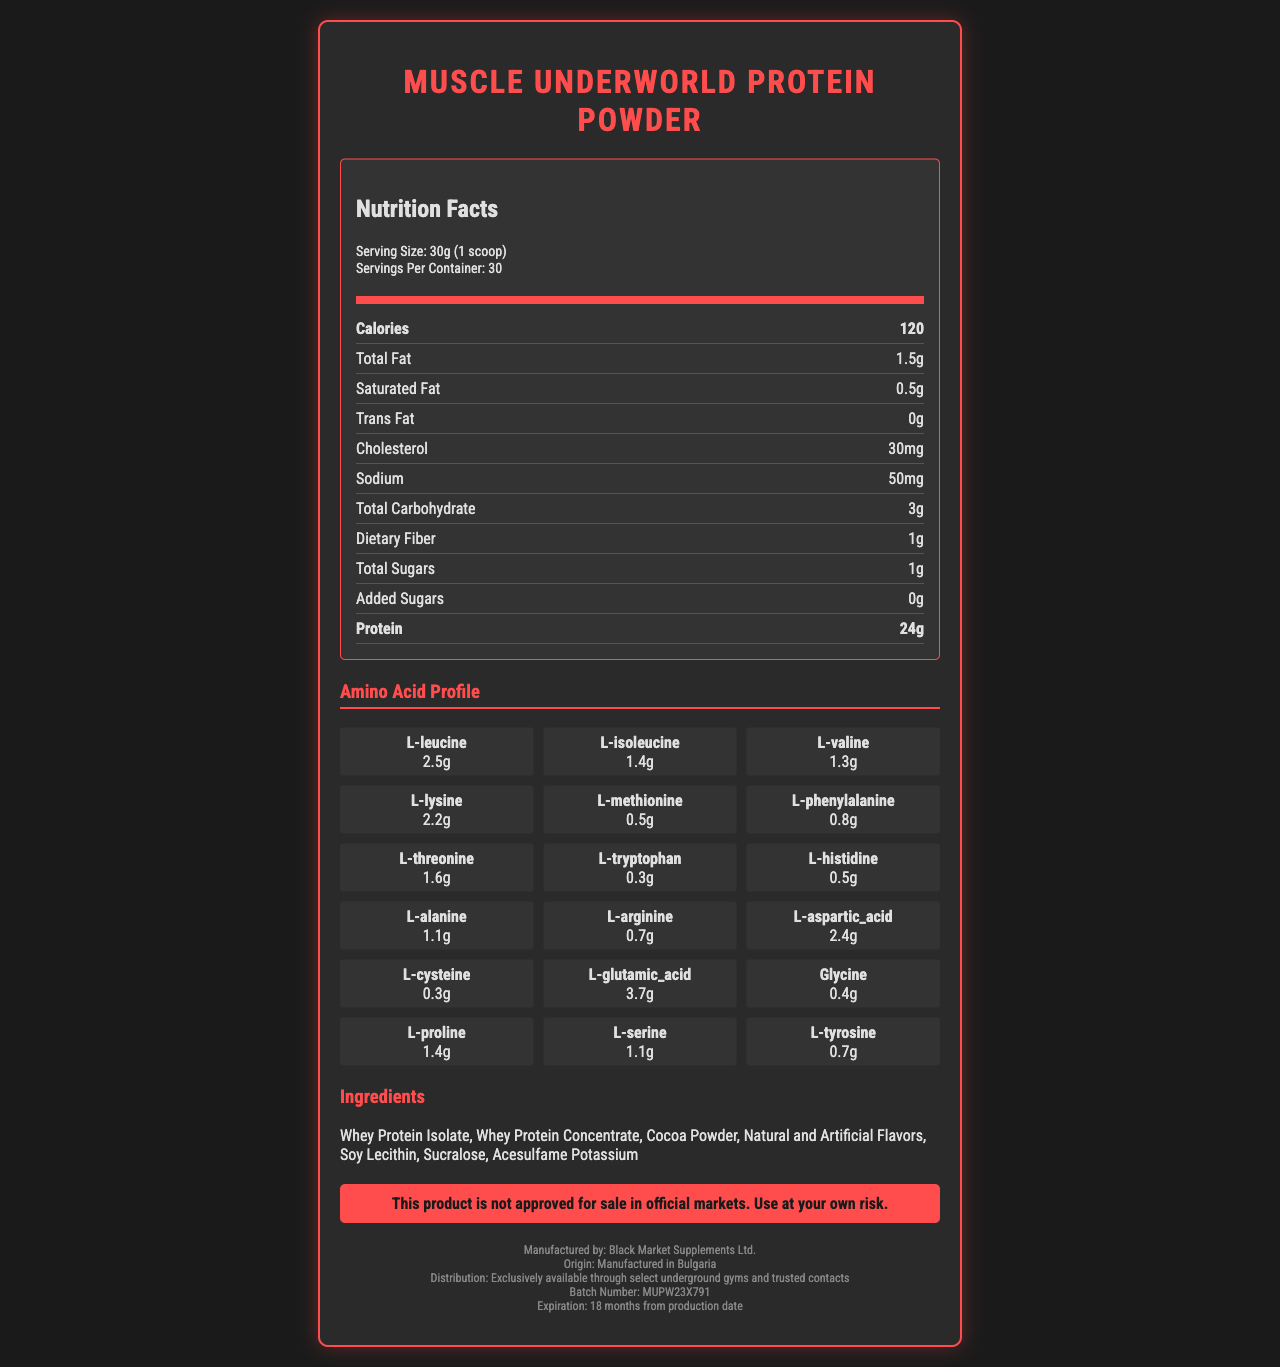what is the serving size of "Muscle Underworld Protein Powder"? The serving size is listed in the section "Serving Size."
Answer: 30g (1 scoop) how many calories are in one serving? The number of calories per serving is listed under the section "Calories."
Answer: 120 what is the total fat content per serving? The total fat content is listed under the section "Total Fat."
Answer: 1.5g how much protein is in each serving? The protein content per serving is listed under the section "Protein."
Answer: 24g what is the amount of L-Leucine per serving? The amount of L-Leucine is listed in the section "Amino Acid Profile."
Answer: 2.5g which two ingredients are primarily used in this protein powder? A. Soy Lecithin and Cocoa Powder B. Whey Protein Isolate and Whey Protein Concentrate C. Sucralose and Acesulfame Potassium D. Natural and Artificial Flavors The primary ingredients are listed in the "Ingredients" section, with the first two being Whey Protein Isolate and Whey Protein Concentrate.
Answer: B. Whey Protein Isolate and Whey Protein Concentrate how much calcium is in a serving? A. 50mg B. 160mg C. 120mg D. 100mg The amount of calcium per serving is listed under the section "Calcium."
Answer: C. 120mg is there any trans fat in this product? The amount of trans fat is listed as 0g in the "Trans Fat" section.
Answer: No does this product contain any added sugars? The amount of added sugars is listed as 0g in the "Added Sugars" section.
Answer: No is this product safe for individuals with peanut allergies? The allergen information states that the product is produced in a facility that also processes peanuts, but it does not confirm the absence of peanuts.
Answer: Cannot be determined what is the country of origin of "Muscle Underworld Protein Powder"? The country of origin is listed as "Manufactured in Bulgaria" in the footer.
Answer: Manufactured in Bulgaria what is the total carbohydrate content per serving? The total carbohydrate content is listed under the section "Total Carbohydrate."
Answer: 3g does this product contain any vitamin D? The amount of Vitamin D is listed as 0 in the "Vitamin D" section.
Answer: No summarize the main idea of the document. The label provides comprehensive information about the product's nutritional values, including macro and micronutrients, specific amino acids, and additional product and safety details.
Answer: The document is a nutrition facts label for "Muscle Underworld Protein Powder," marketed to bodybuilders. It details the serving size, nutritional content, amino acid profile, ingredients, allergen information, manufacturer, origin, and a warning about its non-approval for official markets. 